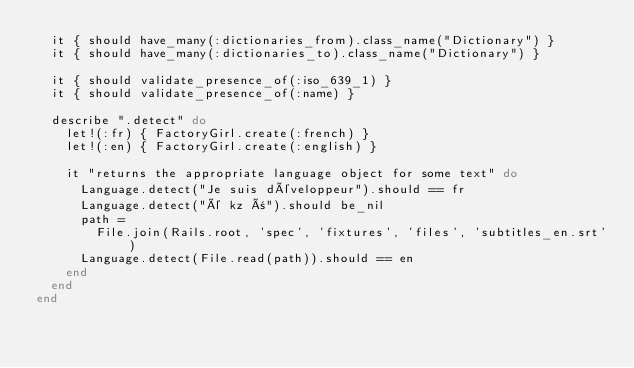<code> <loc_0><loc_0><loc_500><loc_500><_Ruby_>  it { should have_many(:dictionaries_from).class_name("Dictionary") }
  it { should have_many(:dictionaries_to).class_name("Dictionary") }

  it { should validate_presence_of(:iso_639_1) }
  it { should validate_presence_of(:name) }

  describe ".detect" do
    let!(:fr) { FactoryGirl.create(:french) }
    let!(:en) { FactoryGirl.create(:english) }

    it "returns the appropriate language object for some text" do
      Language.detect("Je suis développeur").should == fr
      Language.detect("é kz ñ").should be_nil
      path =
        File.join(Rails.root, 'spec', 'fixtures', 'files', 'subtitles_en.srt')
      Language.detect(File.read(path)).should == en
    end
  end
end
</code> 